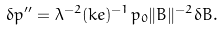Convert formula to latex. <formula><loc_0><loc_0><loc_500><loc_500>\delta p ^ { \prime \prime } = \lambda ^ { - 2 } ( k e ) ^ { - 1 } p _ { 0 } \| B \| ^ { - 2 } \delta B .</formula> 